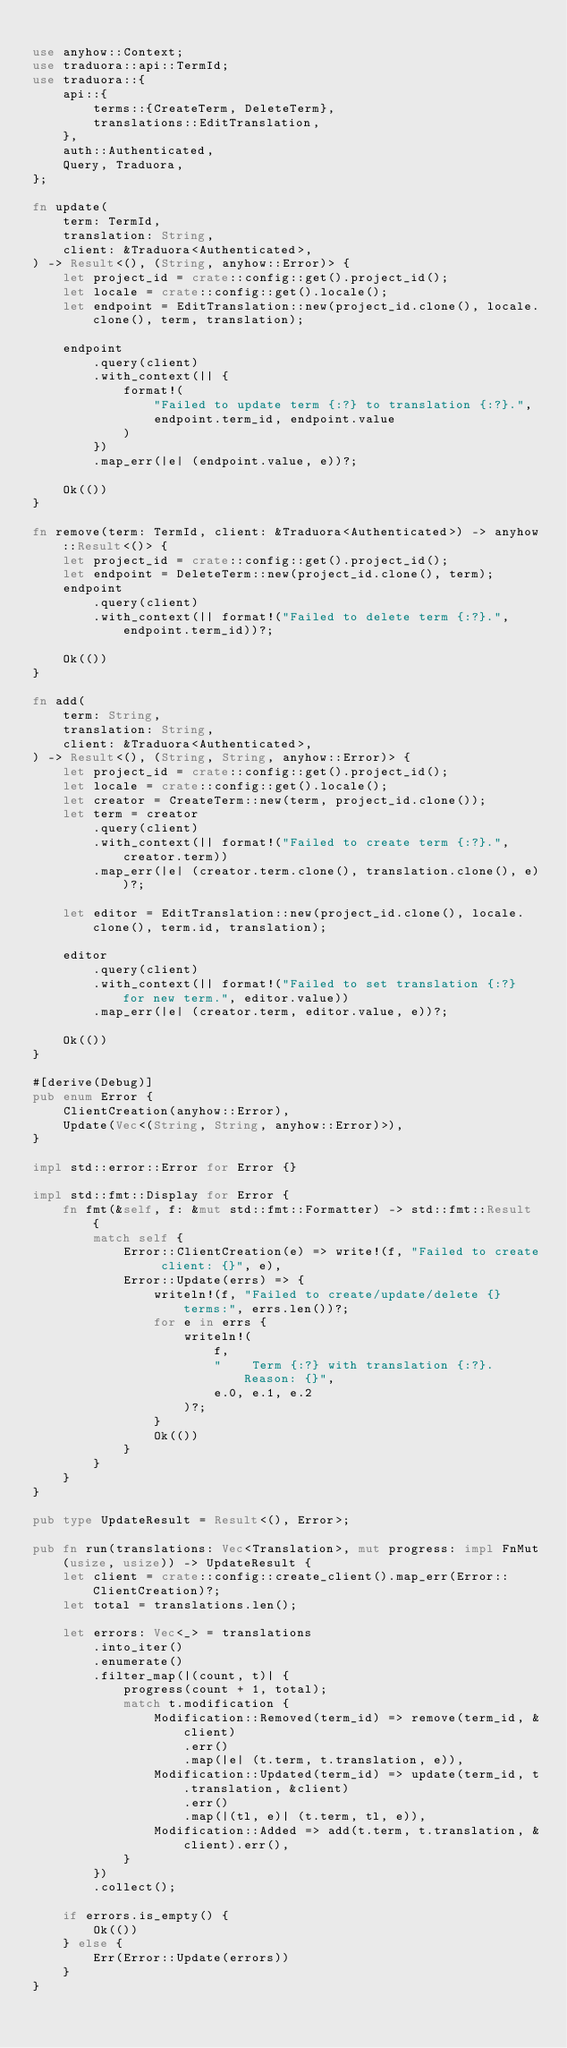<code> <loc_0><loc_0><loc_500><loc_500><_Rust_>
use anyhow::Context;
use traduora::api::TermId;
use traduora::{
    api::{
        terms::{CreateTerm, DeleteTerm},
        translations::EditTranslation,
    },
    auth::Authenticated,
    Query, Traduora,
};

fn update(
    term: TermId,
    translation: String,
    client: &Traduora<Authenticated>,
) -> Result<(), (String, anyhow::Error)> {
    let project_id = crate::config::get().project_id();
    let locale = crate::config::get().locale();
    let endpoint = EditTranslation::new(project_id.clone(), locale.clone(), term, translation);

    endpoint
        .query(client)
        .with_context(|| {
            format!(
                "Failed to update term {:?} to translation {:?}.",
                endpoint.term_id, endpoint.value
            )
        })
        .map_err(|e| (endpoint.value, e))?;

    Ok(())
}

fn remove(term: TermId, client: &Traduora<Authenticated>) -> anyhow::Result<()> {
    let project_id = crate::config::get().project_id();
    let endpoint = DeleteTerm::new(project_id.clone(), term);
    endpoint
        .query(client)
        .with_context(|| format!("Failed to delete term {:?}.", endpoint.term_id))?;

    Ok(())
}

fn add(
    term: String,
    translation: String,
    client: &Traduora<Authenticated>,
) -> Result<(), (String, String, anyhow::Error)> {
    let project_id = crate::config::get().project_id();
    let locale = crate::config::get().locale();
    let creator = CreateTerm::new(term, project_id.clone());
    let term = creator
        .query(client)
        .with_context(|| format!("Failed to create term {:?}.", creator.term))
        .map_err(|e| (creator.term.clone(), translation.clone(), e))?;

    let editor = EditTranslation::new(project_id.clone(), locale.clone(), term.id, translation);

    editor
        .query(client)
        .with_context(|| format!("Failed to set translation {:?} for new term.", editor.value))
        .map_err(|e| (creator.term, editor.value, e))?;

    Ok(())
}

#[derive(Debug)]
pub enum Error {
    ClientCreation(anyhow::Error),
    Update(Vec<(String, String, anyhow::Error)>),
}

impl std::error::Error for Error {}

impl std::fmt::Display for Error {
    fn fmt(&self, f: &mut std::fmt::Formatter) -> std::fmt::Result {
        match self {
            Error::ClientCreation(e) => write!(f, "Failed to create client: {}", e),
            Error::Update(errs) => {
                writeln!(f, "Failed to create/update/delete {} terms:", errs.len())?;
                for e in errs {
                    writeln!(
                        f,
                        "    Term {:?} with translation {:?}. Reason: {}",
                        e.0, e.1, e.2
                    )?;
                }
                Ok(())
            }
        }
    }
}

pub type UpdateResult = Result<(), Error>;

pub fn run(translations: Vec<Translation>, mut progress: impl FnMut(usize, usize)) -> UpdateResult {
    let client = crate::config::create_client().map_err(Error::ClientCreation)?;
    let total = translations.len();

    let errors: Vec<_> = translations
        .into_iter()
        .enumerate()
        .filter_map(|(count, t)| {
            progress(count + 1, total);
            match t.modification {
                Modification::Removed(term_id) => remove(term_id, &client)
                    .err()
                    .map(|e| (t.term, t.translation, e)),
                Modification::Updated(term_id) => update(term_id, t.translation, &client)
                    .err()
                    .map(|(tl, e)| (t.term, tl, e)),
                Modification::Added => add(t.term, t.translation, &client).err(),
            }
        })
        .collect();

    if errors.is_empty() {
        Ok(())
    } else {
        Err(Error::Update(errors))
    }
}
</code> 